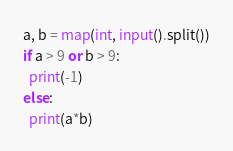Convert code to text. <code><loc_0><loc_0><loc_500><loc_500><_Python_>a, b = map(int, input().split())
if a > 9 or b > 9:
  print(-1)
else:
  print(a*b)</code> 